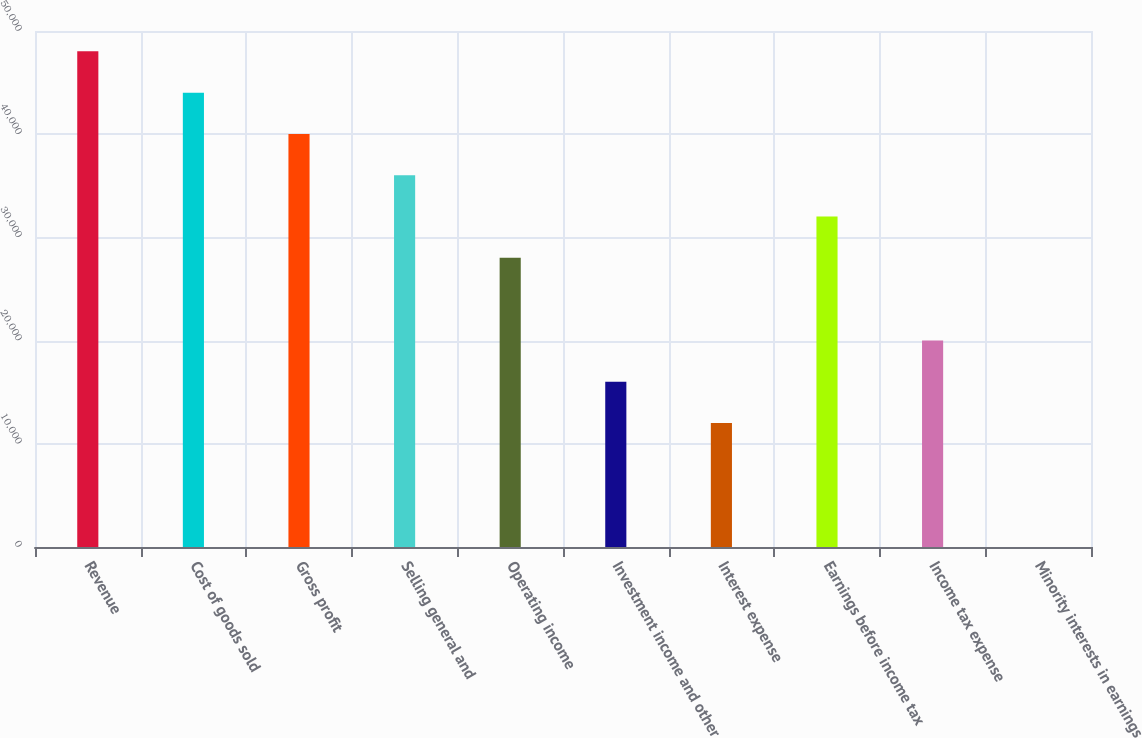Convert chart. <chart><loc_0><loc_0><loc_500><loc_500><bar_chart><fcel>Revenue<fcel>Cost of goods sold<fcel>Gross profit<fcel>Selling general and<fcel>Operating income<fcel>Investment income and other<fcel>Interest expense<fcel>Earnings before income tax<fcel>Income tax expense<fcel>Minority interests in earnings<nl><fcel>48027<fcel>44025<fcel>40023<fcel>36021<fcel>28017<fcel>16011<fcel>12009<fcel>32019<fcel>20013<fcel>3<nl></chart> 